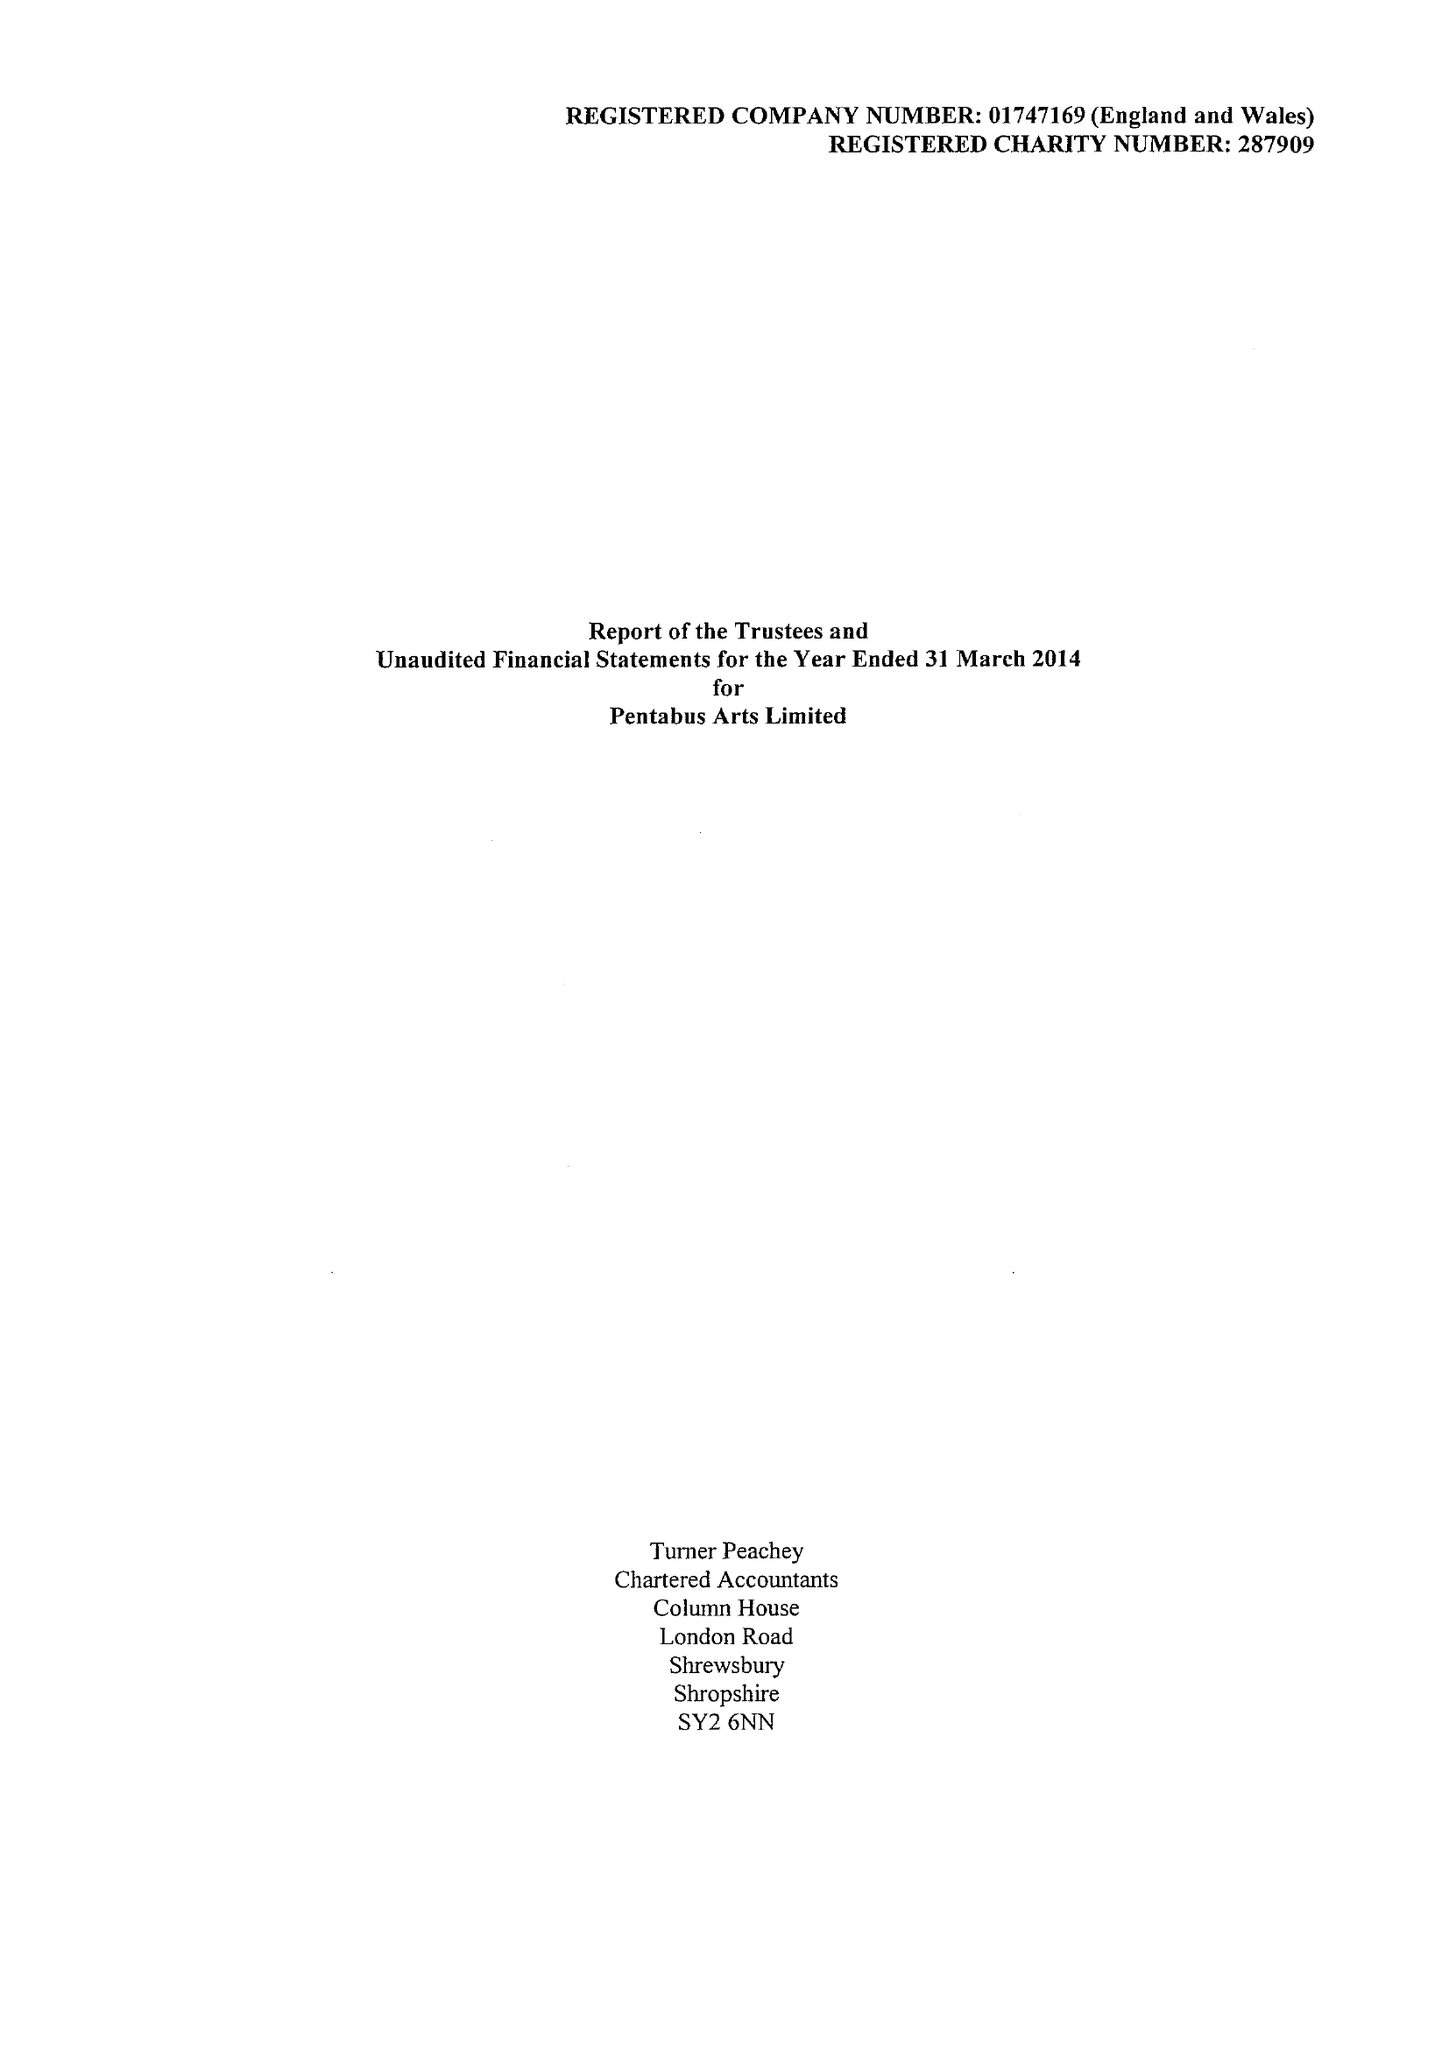What is the value for the spending_annually_in_british_pounds?
Answer the question using a single word or phrase. 236243.00 